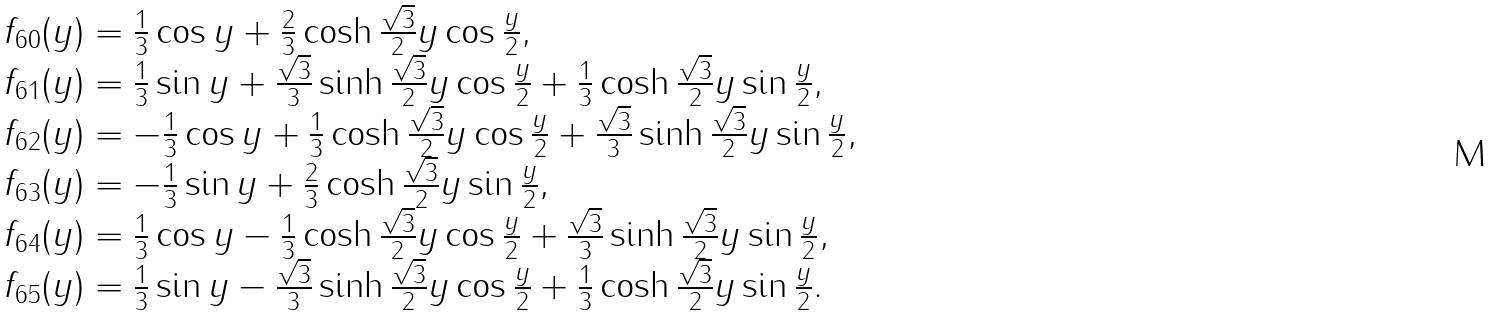<formula> <loc_0><loc_0><loc_500><loc_500>\begin{array} { l } f _ { 6 0 } ( y ) = \frac { 1 } { 3 } \cos y + \frac { 2 } { 3 } \cosh \frac { \sqrt { 3 } } { 2 } y \cos \frac { y } { 2 } , \\ f _ { 6 1 } ( y ) = \frac { 1 } { 3 } \sin y + \frac { \sqrt { 3 } } { 3 } \sinh \frac { \sqrt { 3 } } { 2 } y \cos \frac { y } { 2 } + \frac { 1 } { 3 } \cosh \frac { \sqrt { 3 } } { 2 } y \sin \frac { y } { 2 } , \\ f _ { 6 2 } ( y ) = - \frac { 1 } { 3 } \cos y + \frac { 1 } { 3 } \cosh \frac { \sqrt { 3 } } { 2 } y \cos \frac { y } { 2 } + \frac { \sqrt { 3 } } { 3 } \sinh \frac { \sqrt { 3 } } { 2 } y \sin \frac { y } { 2 } , \\ f _ { 6 3 } ( y ) = - \frac { 1 } { 3 } \sin y + \frac { 2 } { 3 } \cosh \frac { \sqrt { 3 } } { 2 } y \sin \frac { y } { 2 } , \\ f _ { 6 4 } ( y ) = \frac { 1 } { 3 } \cos y - \frac { 1 } { 3 } \cosh \frac { \sqrt { 3 } } { 2 } y \cos \frac { y } { 2 } + \frac { \sqrt { 3 } } { 3 } \sinh \frac { \sqrt { 3 } } { 2 } y \sin \frac { y } { 2 } , \\ f _ { 6 5 } ( y ) = \frac { 1 } { 3 } \sin y - \frac { \sqrt { 3 } } { 3 } \sinh \frac { \sqrt { 3 } } { 2 } y \cos \frac { y } { 2 } + \frac { 1 } { 3 } \cosh \frac { \sqrt { 3 } } { 2 } y \sin \frac { y } { 2 } . \\ \end{array}</formula> 